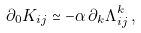Convert formula to latex. <formula><loc_0><loc_0><loc_500><loc_500>\partial _ { 0 } K _ { i j } \simeq - \alpha \, \partial _ { k } \Lambda ^ { k } _ { i j } \, ,</formula> 